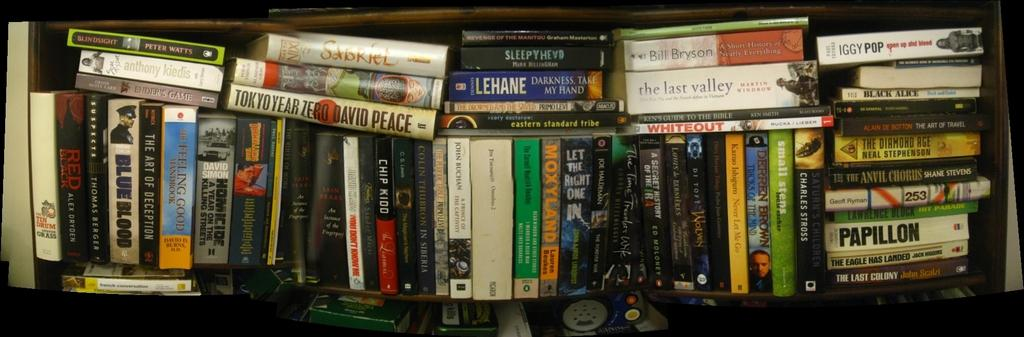<image>
Share a concise interpretation of the image provided. Books are stacked on top of each other including one authored by David Peace. 